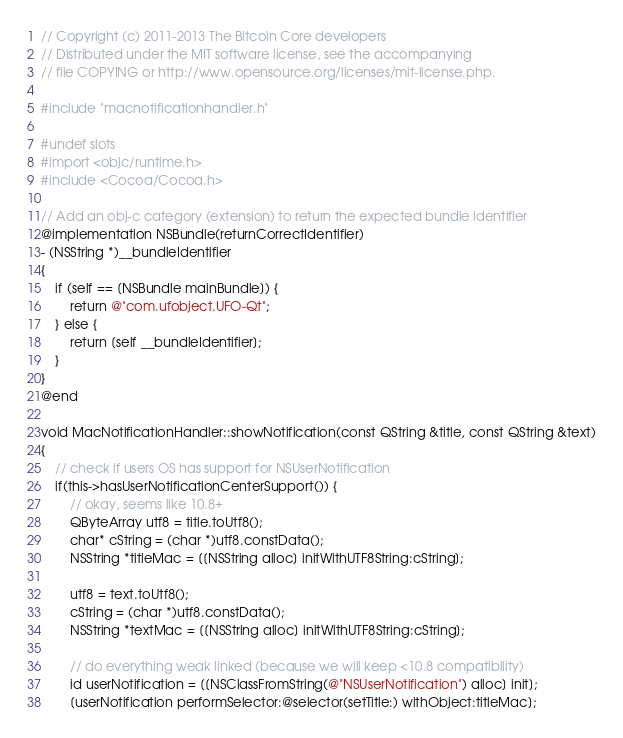<code> <loc_0><loc_0><loc_500><loc_500><_ObjectiveC_>// Copyright (c) 2011-2013 The Bitcoin Core developers
// Distributed under the MIT software license, see the accompanying
// file COPYING or http://www.opensource.org/licenses/mit-license.php.

#include "macnotificationhandler.h"

#undef slots
#import <objc/runtime.h>
#include <Cocoa/Cocoa.h>

// Add an obj-c category (extension) to return the expected bundle identifier
@implementation NSBundle(returnCorrectIdentifier)
- (NSString *)__bundleIdentifier
{
    if (self == [NSBundle mainBundle]) {
        return @"com.ufobject.UFO-Qt";
    } else {
        return [self __bundleIdentifier];
    }
}
@end

void MacNotificationHandler::showNotification(const QString &title, const QString &text)
{
    // check if users OS has support for NSUserNotification
    if(this->hasUserNotificationCenterSupport()) {
        // okay, seems like 10.8+
        QByteArray utf8 = title.toUtf8();
        char* cString = (char *)utf8.constData();
        NSString *titleMac = [[NSString alloc] initWithUTF8String:cString];

        utf8 = text.toUtf8();
        cString = (char *)utf8.constData();
        NSString *textMac = [[NSString alloc] initWithUTF8String:cString];

        // do everything weak linked (because we will keep <10.8 compatibility)
        id userNotification = [[NSClassFromString(@"NSUserNotification") alloc] init];
        [userNotification performSelector:@selector(setTitle:) withObject:titleMac];</code> 